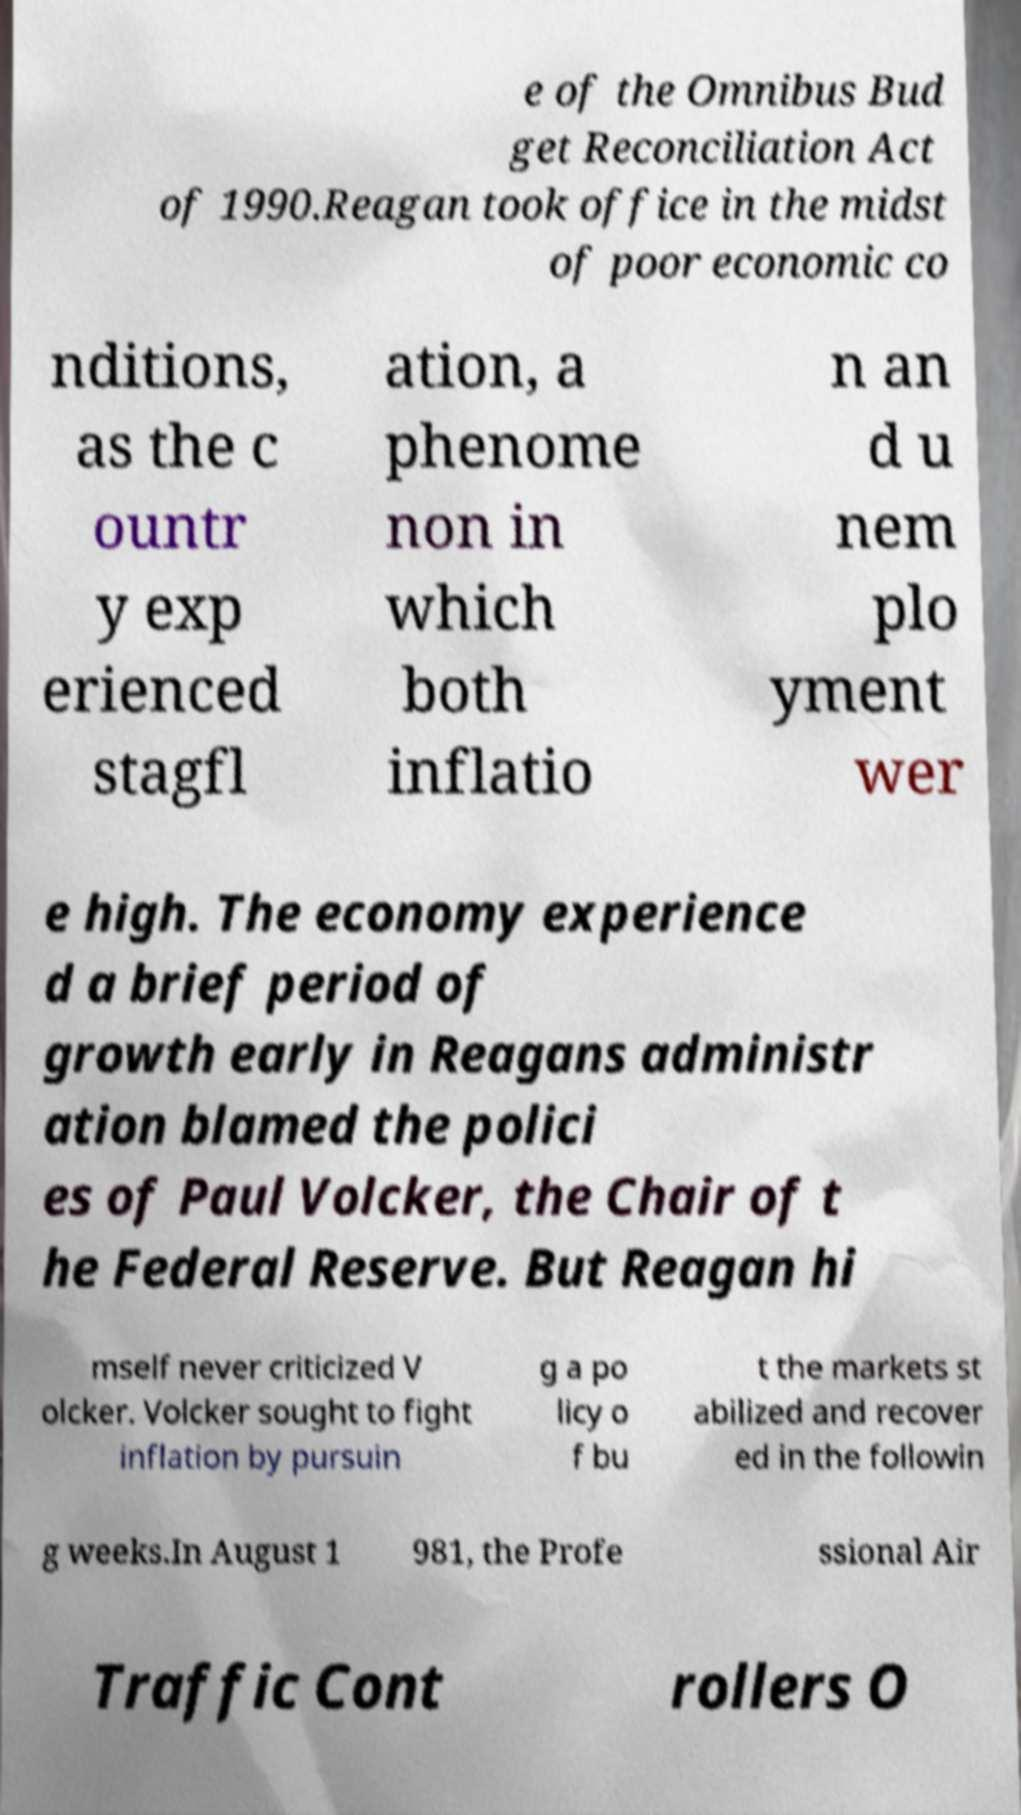There's text embedded in this image that I need extracted. Can you transcribe it verbatim? e of the Omnibus Bud get Reconciliation Act of 1990.Reagan took office in the midst of poor economic co nditions, as the c ountr y exp erienced stagfl ation, a phenome non in which both inflatio n an d u nem plo yment wer e high. The economy experience d a brief period of growth early in Reagans administr ation blamed the polici es of Paul Volcker, the Chair of t he Federal Reserve. But Reagan hi mself never criticized V olcker. Volcker sought to fight inflation by pursuin g a po licy o f bu t the markets st abilized and recover ed in the followin g weeks.In August 1 981, the Profe ssional Air Traffic Cont rollers O 